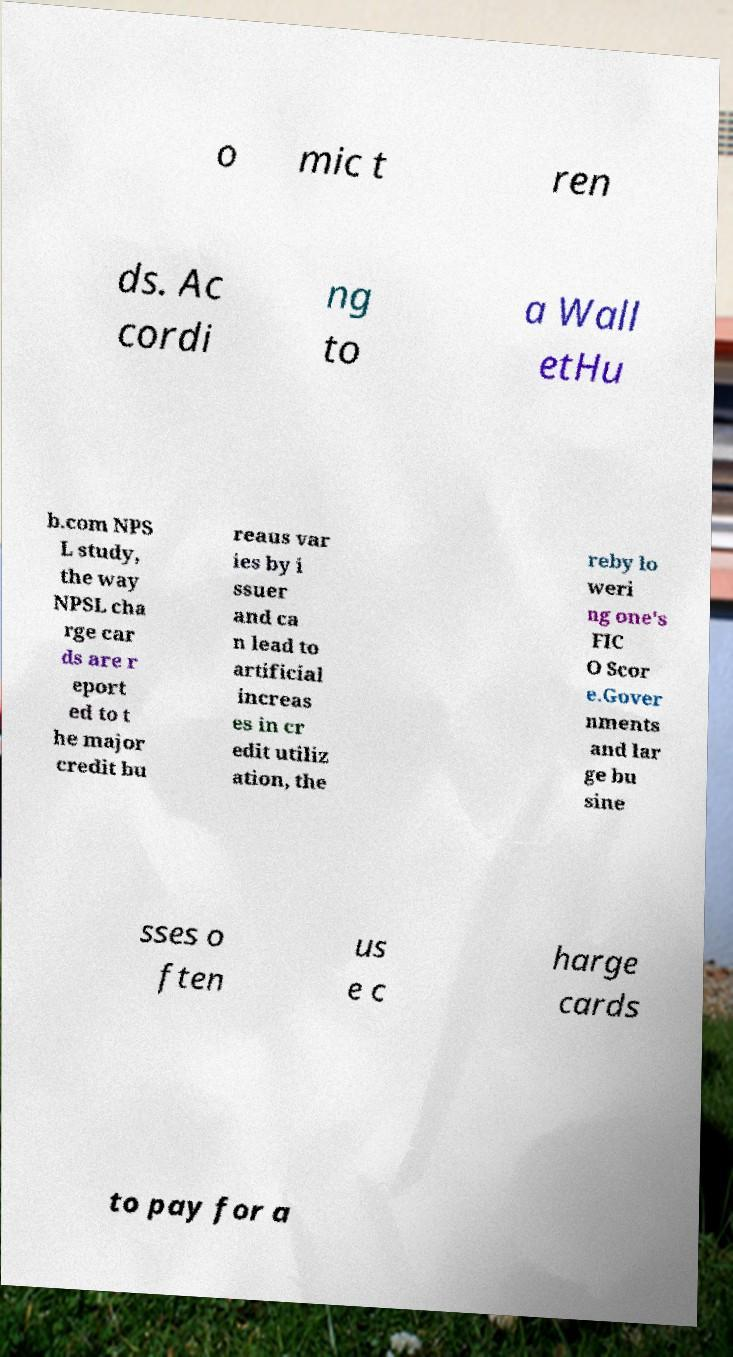I need the written content from this picture converted into text. Can you do that? o mic t ren ds. Ac cordi ng to a Wall etHu b.com NPS L study, the way NPSL cha rge car ds are r eport ed to t he major credit bu reaus var ies by i ssuer and ca n lead to artificial increas es in cr edit utiliz ation, the reby lo weri ng one's FIC O Scor e.Gover nments and lar ge bu sine sses o ften us e c harge cards to pay for a 